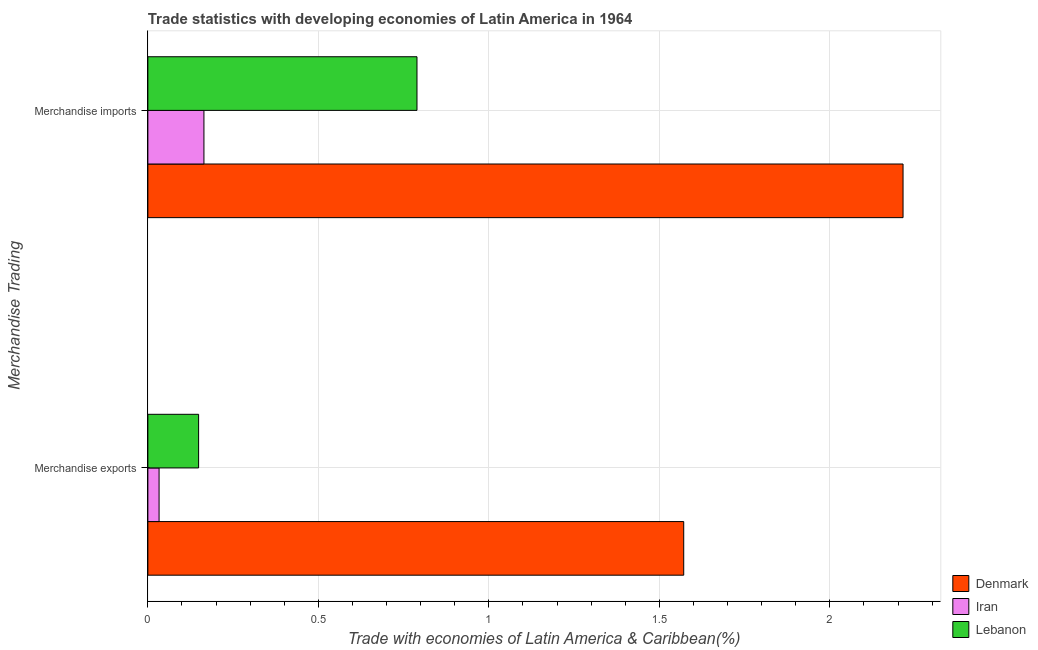How many different coloured bars are there?
Make the answer very short. 3. Are the number of bars per tick equal to the number of legend labels?
Offer a very short reply. Yes. How many bars are there on the 1st tick from the bottom?
Offer a very short reply. 3. What is the label of the 2nd group of bars from the top?
Offer a very short reply. Merchandise exports. What is the merchandise imports in Denmark?
Offer a terse response. 2.21. Across all countries, what is the maximum merchandise imports?
Offer a terse response. 2.21. Across all countries, what is the minimum merchandise exports?
Ensure brevity in your answer.  0.03. In which country was the merchandise exports minimum?
Your answer should be very brief. Iran. What is the total merchandise imports in the graph?
Your response must be concise. 3.17. What is the difference between the merchandise exports in Lebanon and that in Denmark?
Provide a short and direct response. -1.42. What is the difference between the merchandise exports in Denmark and the merchandise imports in Iran?
Offer a very short reply. 1.41. What is the average merchandise imports per country?
Your answer should be compact. 1.06. What is the difference between the merchandise exports and merchandise imports in Lebanon?
Keep it short and to the point. -0.64. What is the ratio of the merchandise exports in Lebanon to that in Denmark?
Make the answer very short. 0.09. Is the merchandise exports in Denmark less than that in Iran?
Make the answer very short. No. What does the 1st bar from the top in Merchandise imports represents?
Your response must be concise. Lebanon. What does the 2nd bar from the bottom in Merchandise exports represents?
Your response must be concise. Iran. Are all the bars in the graph horizontal?
Your response must be concise. Yes. Where does the legend appear in the graph?
Keep it short and to the point. Bottom right. How many legend labels are there?
Make the answer very short. 3. How are the legend labels stacked?
Your answer should be very brief. Vertical. What is the title of the graph?
Provide a succinct answer. Trade statistics with developing economies of Latin America in 1964. Does "Virgin Islands" appear as one of the legend labels in the graph?
Ensure brevity in your answer.  No. What is the label or title of the X-axis?
Your response must be concise. Trade with economies of Latin America & Caribbean(%). What is the label or title of the Y-axis?
Provide a succinct answer. Merchandise Trading. What is the Trade with economies of Latin America & Caribbean(%) in Denmark in Merchandise exports?
Your response must be concise. 1.57. What is the Trade with economies of Latin America & Caribbean(%) of Iran in Merchandise exports?
Provide a short and direct response. 0.03. What is the Trade with economies of Latin America & Caribbean(%) of Lebanon in Merchandise exports?
Offer a very short reply. 0.15. What is the Trade with economies of Latin America & Caribbean(%) of Denmark in Merchandise imports?
Your answer should be compact. 2.21. What is the Trade with economies of Latin America & Caribbean(%) of Iran in Merchandise imports?
Make the answer very short. 0.16. What is the Trade with economies of Latin America & Caribbean(%) in Lebanon in Merchandise imports?
Offer a terse response. 0.79. Across all Merchandise Trading, what is the maximum Trade with economies of Latin America & Caribbean(%) of Denmark?
Give a very brief answer. 2.21. Across all Merchandise Trading, what is the maximum Trade with economies of Latin America & Caribbean(%) of Iran?
Ensure brevity in your answer.  0.16. Across all Merchandise Trading, what is the maximum Trade with economies of Latin America & Caribbean(%) of Lebanon?
Offer a very short reply. 0.79. Across all Merchandise Trading, what is the minimum Trade with economies of Latin America & Caribbean(%) of Denmark?
Offer a terse response. 1.57. Across all Merchandise Trading, what is the minimum Trade with economies of Latin America & Caribbean(%) in Iran?
Your answer should be compact. 0.03. Across all Merchandise Trading, what is the minimum Trade with economies of Latin America & Caribbean(%) of Lebanon?
Provide a short and direct response. 0.15. What is the total Trade with economies of Latin America & Caribbean(%) in Denmark in the graph?
Your response must be concise. 3.79. What is the total Trade with economies of Latin America & Caribbean(%) in Iran in the graph?
Give a very brief answer. 0.2. What is the total Trade with economies of Latin America & Caribbean(%) in Lebanon in the graph?
Give a very brief answer. 0.94. What is the difference between the Trade with economies of Latin America & Caribbean(%) of Denmark in Merchandise exports and that in Merchandise imports?
Ensure brevity in your answer.  -0.64. What is the difference between the Trade with economies of Latin America & Caribbean(%) of Iran in Merchandise exports and that in Merchandise imports?
Offer a very short reply. -0.13. What is the difference between the Trade with economies of Latin America & Caribbean(%) in Lebanon in Merchandise exports and that in Merchandise imports?
Offer a very short reply. -0.64. What is the difference between the Trade with economies of Latin America & Caribbean(%) of Denmark in Merchandise exports and the Trade with economies of Latin America & Caribbean(%) of Iran in Merchandise imports?
Give a very brief answer. 1.41. What is the difference between the Trade with economies of Latin America & Caribbean(%) in Denmark in Merchandise exports and the Trade with economies of Latin America & Caribbean(%) in Lebanon in Merchandise imports?
Offer a very short reply. 0.78. What is the difference between the Trade with economies of Latin America & Caribbean(%) of Iran in Merchandise exports and the Trade with economies of Latin America & Caribbean(%) of Lebanon in Merchandise imports?
Offer a very short reply. -0.76. What is the average Trade with economies of Latin America & Caribbean(%) of Denmark per Merchandise Trading?
Offer a very short reply. 1.89. What is the average Trade with economies of Latin America & Caribbean(%) of Iran per Merchandise Trading?
Offer a terse response. 0.1. What is the average Trade with economies of Latin America & Caribbean(%) in Lebanon per Merchandise Trading?
Your answer should be compact. 0.47. What is the difference between the Trade with economies of Latin America & Caribbean(%) in Denmark and Trade with economies of Latin America & Caribbean(%) in Iran in Merchandise exports?
Ensure brevity in your answer.  1.54. What is the difference between the Trade with economies of Latin America & Caribbean(%) in Denmark and Trade with economies of Latin America & Caribbean(%) in Lebanon in Merchandise exports?
Your response must be concise. 1.42. What is the difference between the Trade with economies of Latin America & Caribbean(%) in Iran and Trade with economies of Latin America & Caribbean(%) in Lebanon in Merchandise exports?
Your response must be concise. -0.12. What is the difference between the Trade with economies of Latin America & Caribbean(%) in Denmark and Trade with economies of Latin America & Caribbean(%) in Iran in Merchandise imports?
Ensure brevity in your answer.  2.05. What is the difference between the Trade with economies of Latin America & Caribbean(%) in Denmark and Trade with economies of Latin America & Caribbean(%) in Lebanon in Merchandise imports?
Ensure brevity in your answer.  1.43. What is the difference between the Trade with economies of Latin America & Caribbean(%) of Iran and Trade with economies of Latin America & Caribbean(%) of Lebanon in Merchandise imports?
Make the answer very short. -0.62. What is the ratio of the Trade with economies of Latin America & Caribbean(%) in Denmark in Merchandise exports to that in Merchandise imports?
Your answer should be compact. 0.71. What is the ratio of the Trade with economies of Latin America & Caribbean(%) of Iran in Merchandise exports to that in Merchandise imports?
Provide a succinct answer. 0.2. What is the ratio of the Trade with economies of Latin America & Caribbean(%) of Lebanon in Merchandise exports to that in Merchandise imports?
Your answer should be compact. 0.19. What is the difference between the highest and the second highest Trade with economies of Latin America & Caribbean(%) in Denmark?
Provide a short and direct response. 0.64. What is the difference between the highest and the second highest Trade with economies of Latin America & Caribbean(%) in Iran?
Offer a terse response. 0.13. What is the difference between the highest and the second highest Trade with economies of Latin America & Caribbean(%) in Lebanon?
Give a very brief answer. 0.64. What is the difference between the highest and the lowest Trade with economies of Latin America & Caribbean(%) in Denmark?
Make the answer very short. 0.64. What is the difference between the highest and the lowest Trade with economies of Latin America & Caribbean(%) of Iran?
Keep it short and to the point. 0.13. What is the difference between the highest and the lowest Trade with economies of Latin America & Caribbean(%) in Lebanon?
Give a very brief answer. 0.64. 